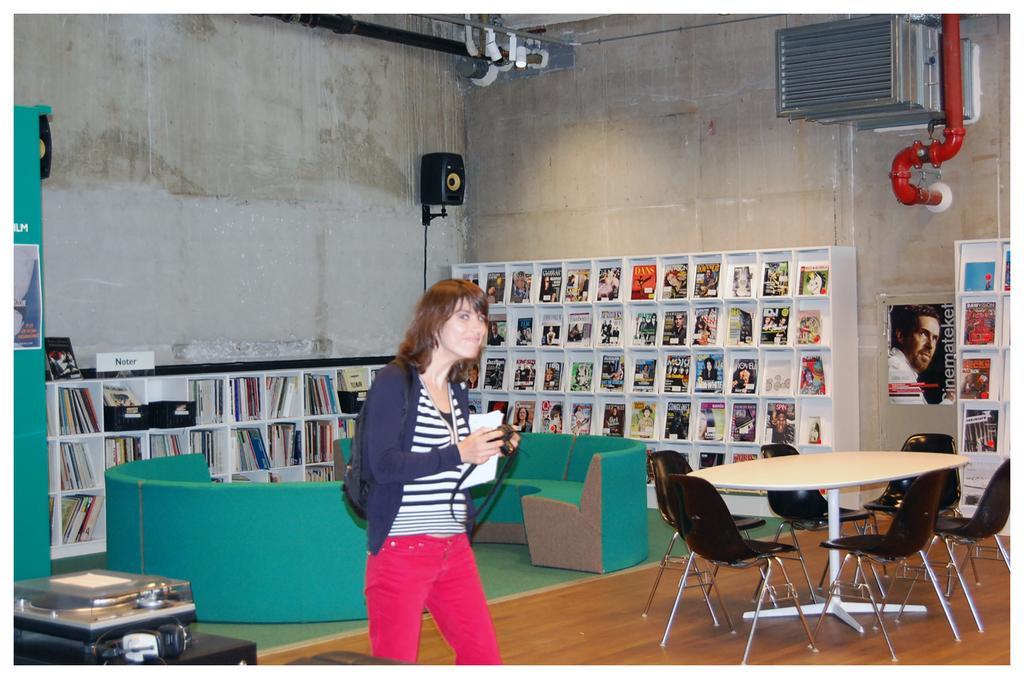Describe this image in one or two sentences. This is the picture of a woman standing in a room and in back ground there are books in racks , speaker , table , chair , couch and a pipe. 